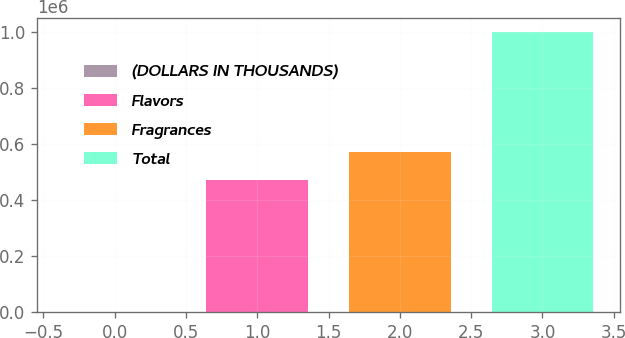Convert chart. <chart><loc_0><loc_0><loc_500><loc_500><bar_chart><fcel>(DOLLARS IN THOUSANDS)<fcel>Flavors<fcel>Fragrances<fcel>Total<nl><fcel>2016<fcel>473820<fcel>573631<fcel>1.00012e+06<nl></chart> 